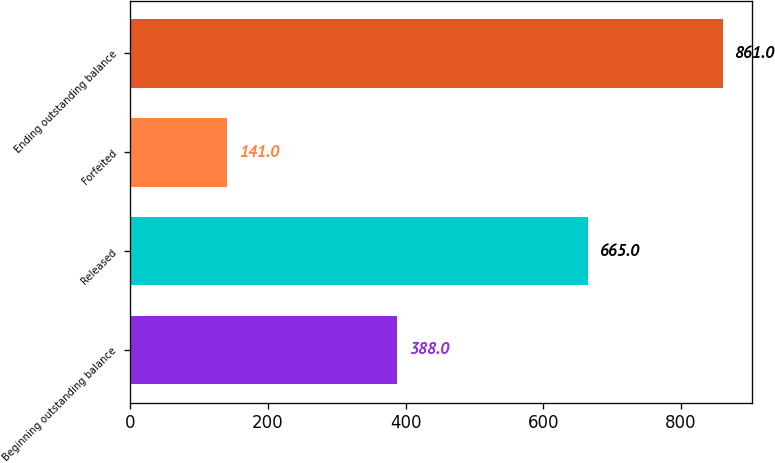Convert chart. <chart><loc_0><loc_0><loc_500><loc_500><bar_chart><fcel>Beginning outstanding balance<fcel>Released<fcel>Forfeited<fcel>Ending outstanding balance<nl><fcel>388<fcel>665<fcel>141<fcel>861<nl></chart> 